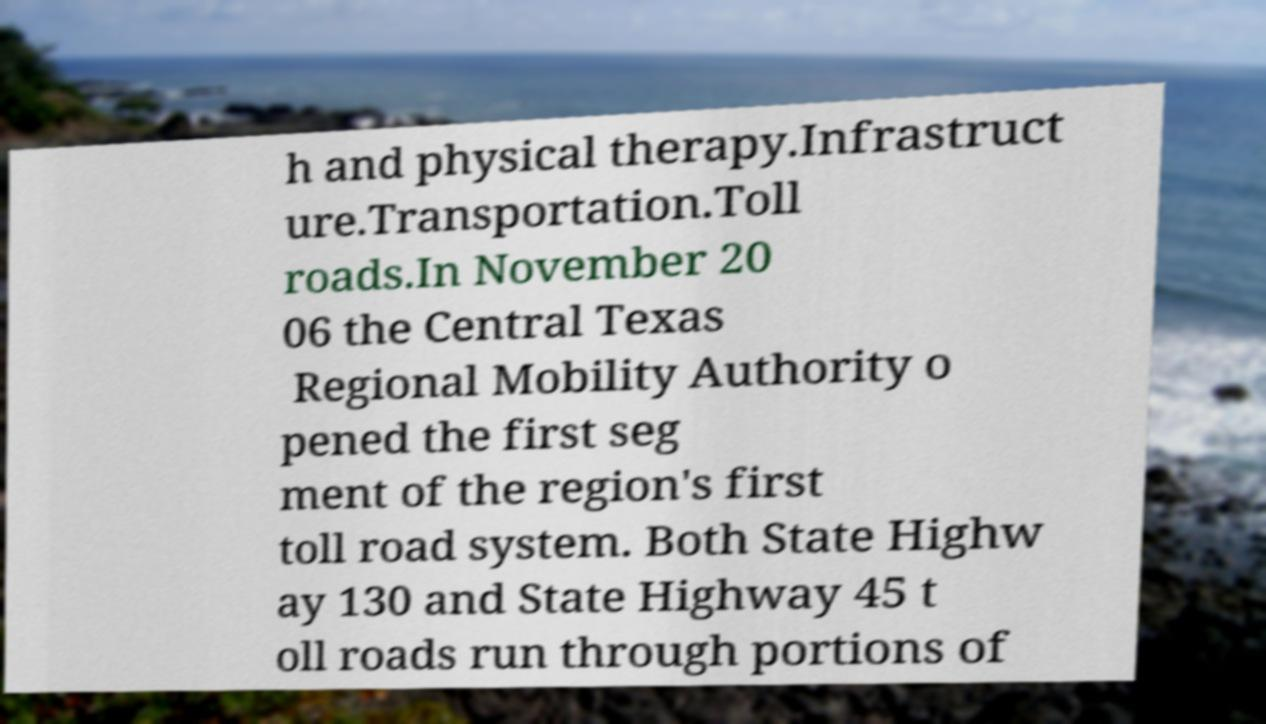What messages or text are displayed in this image? I need them in a readable, typed format. h and physical therapy.Infrastruct ure.Transportation.Toll roads.In November 20 06 the Central Texas Regional Mobility Authority o pened the first seg ment of the region's first toll road system. Both State Highw ay 130 and State Highway 45 t oll roads run through portions of 